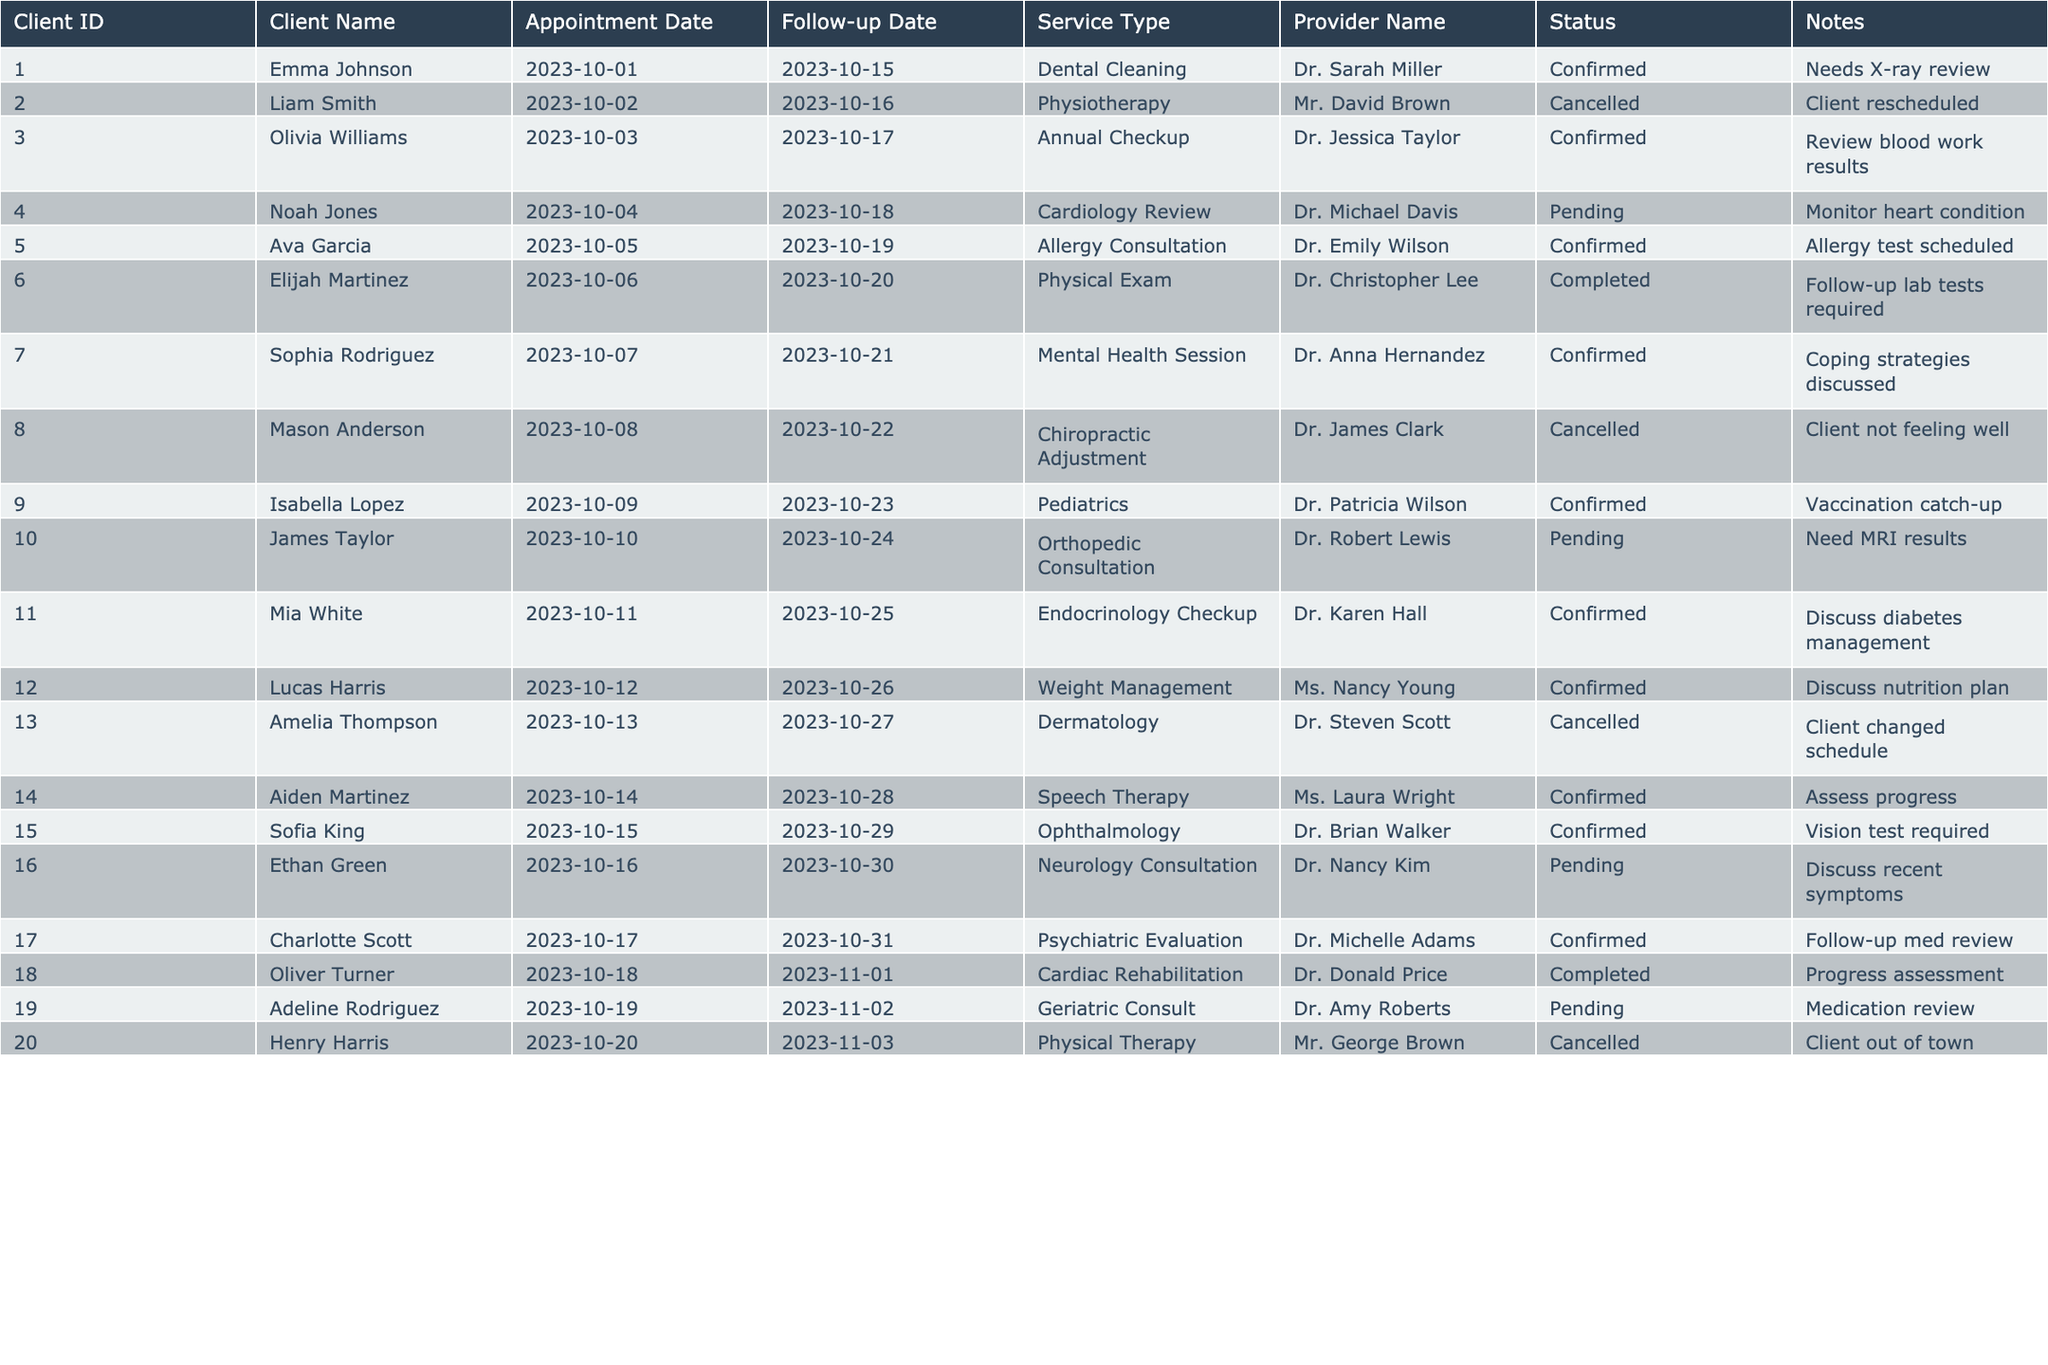What is the follow-up date for Emma Johnson? Emma Johnson's row in the table shows that her follow-up date is 2023-10-15, which is listed directly in the Follow-up Date column.
Answer: 2023-10-15 How many appointments were cancelled? By counting the entries in the Status column, there are 4 instances where the Status is marked as Cancelled.
Answer: 4 Who is the provider for the Mental Health Session? The provider for the Mental Health Session can be found in the row for Sophia Rodriguez, showing Dr. Anna Hernandez as the provider.
Answer: Dr. Anna Hernandez What is the service type for the client with ID 015? Looking at the row for Client ID 015 (Sofia King), the service type is listed as Ophthalmology.
Answer: Ophthalmology Are there any follow-up appointments scheduled on the same day? By checking the Follow-up Date column, it can be seen that multiple clients, such as Emma Johnson and Ava Garcia, have follow-up appointments on the same day (2023-10-15).
Answer: Yes What is the appointment status for the client who is scheduled for a neurology consultation? Referring to the row for Ethan Green (Client ID 016), the status shows Pending, indicating that the appointment is not yet confirmed.
Answer: Pending How many total clients are scheduled for appointments with a confirmed status? There are a total of 11 clients with the status Confirmed, counted from the Status column.
Answer: 11 What is the difference in days between the earliest appointment and the latest follow-up appointment? The earliest appointment date is 2023-10-01 (for Emma Johnson) and the latest follow-up date is 2023-11-03 (for Henry Harris). The difference in days is calculated as November 3 - October 1, which is 33 days.
Answer: 33 days Is there any client scheduled for a cardiac rehabilitation follow-up? Checking the table, Oliver Turner has a follow-up appointment for Cardiac Rehabilitation, which confirms the answer is yes.
Answer: Yes What percentage of clients have completed their appointment? Out of 20 clients, 2 have a completed status. Thus, (2/20) * 100 = 10%.
Answer: 10% 